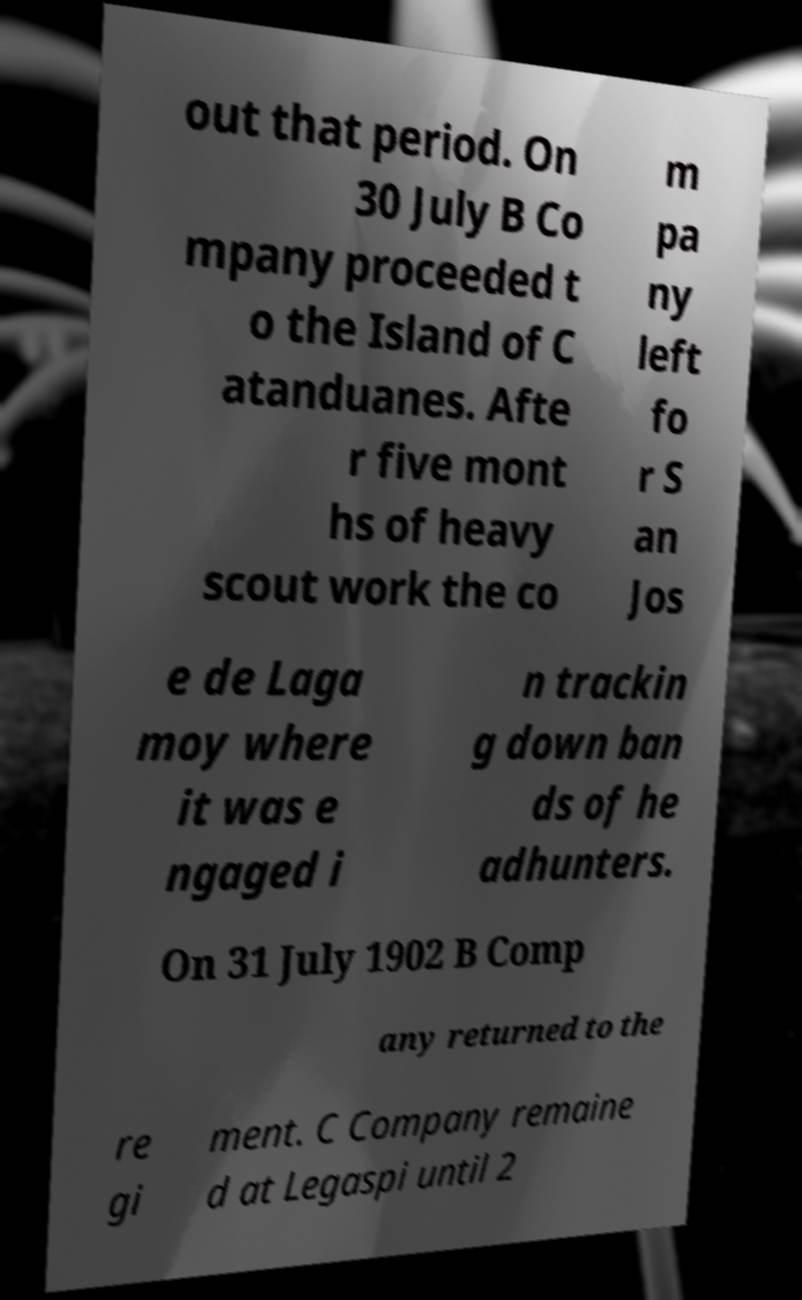What messages or text are displayed in this image? I need them in a readable, typed format. out that period. On 30 July B Co mpany proceeded t o the Island of C atanduanes. Afte r five mont hs of heavy scout work the co m pa ny left fo r S an Jos e de Laga moy where it was e ngaged i n trackin g down ban ds of he adhunters. On 31 July 1902 B Comp any returned to the re gi ment. C Company remaine d at Legaspi until 2 